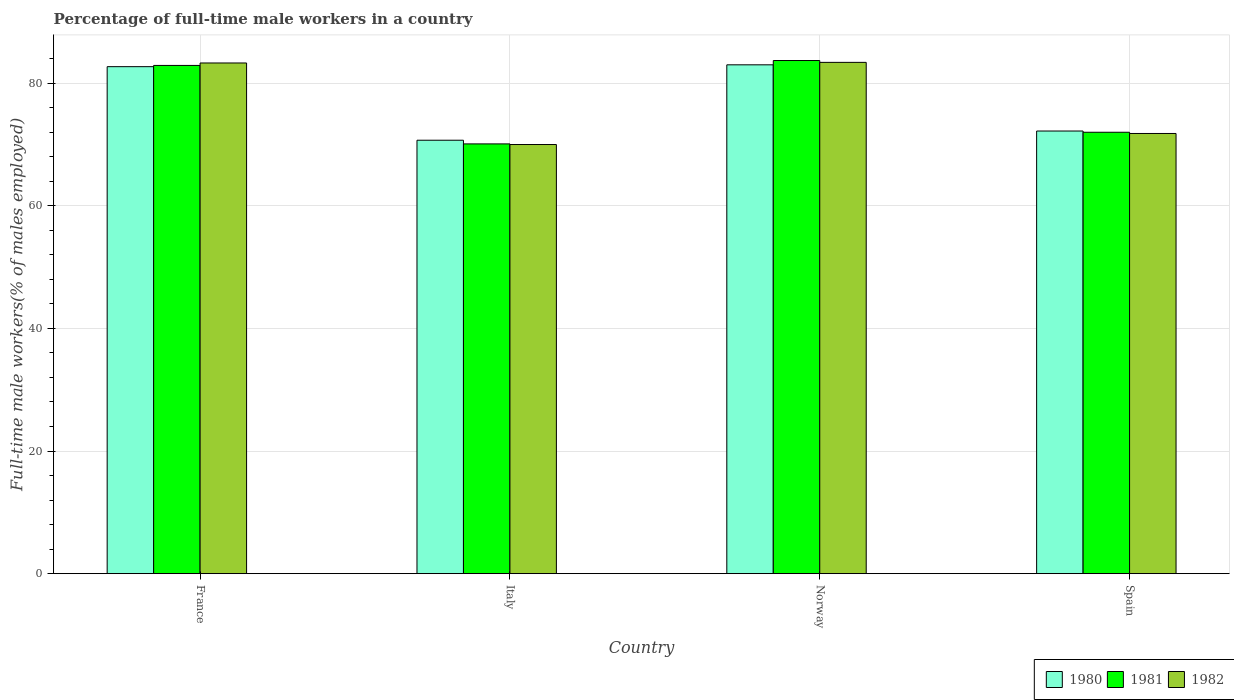Are the number of bars on each tick of the X-axis equal?
Make the answer very short. Yes. How many bars are there on the 4th tick from the left?
Offer a terse response. 3. How many bars are there on the 4th tick from the right?
Provide a short and direct response. 3. What is the label of the 2nd group of bars from the left?
Your answer should be very brief. Italy. In how many cases, is the number of bars for a given country not equal to the number of legend labels?
Offer a very short reply. 0. Across all countries, what is the maximum percentage of full-time male workers in 1982?
Your answer should be compact. 83.4. Across all countries, what is the minimum percentage of full-time male workers in 1980?
Offer a very short reply. 70.7. What is the total percentage of full-time male workers in 1981 in the graph?
Keep it short and to the point. 308.7. What is the difference between the percentage of full-time male workers in 1982 in Spain and the percentage of full-time male workers in 1981 in Norway?
Keep it short and to the point. -11.9. What is the average percentage of full-time male workers in 1981 per country?
Make the answer very short. 77.17. What is the difference between the percentage of full-time male workers of/in 1981 and percentage of full-time male workers of/in 1982 in France?
Offer a terse response. -0.4. In how many countries, is the percentage of full-time male workers in 1981 greater than 24 %?
Your answer should be very brief. 4. What is the ratio of the percentage of full-time male workers in 1982 in Italy to that in Norway?
Provide a short and direct response. 0.84. Is the percentage of full-time male workers in 1981 in Norway less than that in Spain?
Your response must be concise. No. Is the difference between the percentage of full-time male workers in 1981 in France and Italy greater than the difference between the percentage of full-time male workers in 1982 in France and Italy?
Provide a short and direct response. No. What is the difference between the highest and the lowest percentage of full-time male workers in 1982?
Give a very brief answer. 13.4. What does the 3rd bar from the right in Norway represents?
Your answer should be very brief. 1980. Are all the bars in the graph horizontal?
Provide a succinct answer. No. How many countries are there in the graph?
Provide a succinct answer. 4. What is the difference between two consecutive major ticks on the Y-axis?
Make the answer very short. 20. Are the values on the major ticks of Y-axis written in scientific E-notation?
Offer a terse response. No. Does the graph contain any zero values?
Ensure brevity in your answer.  No. How many legend labels are there?
Ensure brevity in your answer.  3. How are the legend labels stacked?
Your response must be concise. Horizontal. What is the title of the graph?
Keep it short and to the point. Percentage of full-time male workers in a country. Does "1982" appear as one of the legend labels in the graph?
Ensure brevity in your answer.  Yes. What is the label or title of the X-axis?
Give a very brief answer. Country. What is the label or title of the Y-axis?
Offer a terse response. Full-time male workers(% of males employed). What is the Full-time male workers(% of males employed) of 1980 in France?
Your response must be concise. 82.7. What is the Full-time male workers(% of males employed) in 1981 in France?
Offer a very short reply. 82.9. What is the Full-time male workers(% of males employed) of 1982 in France?
Your answer should be compact. 83.3. What is the Full-time male workers(% of males employed) in 1980 in Italy?
Make the answer very short. 70.7. What is the Full-time male workers(% of males employed) of 1981 in Italy?
Ensure brevity in your answer.  70.1. What is the Full-time male workers(% of males employed) of 1980 in Norway?
Your answer should be very brief. 83. What is the Full-time male workers(% of males employed) of 1981 in Norway?
Your answer should be compact. 83.7. What is the Full-time male workers(% of males employed) in 1982 in Norway?
Provide a succinct answer. 83.4. What is the Full-time male workers(% of males employed) in 1980 in Spain?
Ensure brevity in your answer.  72.2. What is the Full-time male workers(% of males employed) of 1981 in Spain?
Ensure brevity in your answer.  72. What is the Full-time male workers(% of males employed) in 1982 in Spain?
Offer a terse response. 71.8. Across all countries, what is the maximum Full-time male workers(% of males employed) in 1980?
Make the answer very short. 83. Across all countries, what is the maximum Full-time male workers(% of males employed) of 1981?
Make the answer very short. 83.7. Across all countries, what is the maximum Full-time male workers(% of males employed) in 1982?
Provide a short and direct response. 83.4. Across all countries, what is the minimum Full-time male workers(% of males employed) of 1980?
Ensure brevity in your answer.  70.7. Across all countries, what is the minimum Full-time male workers(% of males employed) in 1981?
Your response must be concise. 70.1. What is the total Full-time male workers(% of males employed) of 1980 in the graph?
Keep it short and to the point. 308.6. What is the total Full-time male workers(% of males employed) in 1981 in the graph?
Your answer should be compact. 308.7. What is the total Full-time male workers(% of males employed) in 1982 in the graph?
Offer a terse response. 308.5. What is the difference between the Full-time male workers(% of males employed) in 1980 in France and that in Italy?
Provide a short and direct response. 12. What is the difference between the Full-time male workers(% of males employed) of 1980 in France and that in Spain?
Your response must be concise. 10.5. What is the difference between the Full-time male workers(% of males employed) of 1982 in France and that in Spain?
Your answer should be very brief. 11.5. What is the difference between the Full-time male workers(% of males employed) in 1980 in Italy and that in Spain?
Your answer should be compact. -1.5. What is the difference between the Full-time male workers(% of males employed) in 1982 in Italy and that in Spain?
Your answer should be very brief. -1.8. What is the difference between the Full-time male workers(% of males employed) in 1981 in Norway and that in Spain?
Your answer should be compact. 11.7. What is the difference between the Full-time male workers(% of males employed) in 1980 in France and the Full-time male workers(% of males employed) in 1982 in Italy?
Your response must be concise. 12.7. What is the difference between the Full-time male workers(% of males employed) in 1980 in France and the Full-time male workers(% of males employed) in 1981 in Norway?
Keep it short and to the point. -1. What is the difference between the Full-time male workers(% of males employed) of 1980 in France and the Full-time male workers(% of males employed) of 1982 in Norway?
Make the answer very short. -0.7. What is the difference between the Full-time male workers(% of males employed) in 1981 in France and the Full-time male workers(% of males employed) in 1982 in Norway?
Ensure brevity in your answer.  -0.5. What is the difference between the Full-time male workers(% of males employed) in 1980 in France and the Full-time male workers(% of males employed) in 1982 in Spain?
Offer a terse response. 10.9. What is the difference between the Full-time male workers(% of males employed) of 1981 in France and the Full-time male workers(% of males employed) of 1982 in Spain?
Give a very brief answer. 11.1. What is the difference between the Full-time male workers(% of males employed) of 1980 in Italy and the Full-time male workers(% of males employed) of 1981 in Norway?
Provide a succinct answer. -13. What is the difference between the Full-time male workers(% of males employed) in 1981 in Italy and the Full-time male workers(% of males employed) in 1982 in Norway?
Your answer should be compact. -13.3. What is the average Full-time male workers(% of males employed) in 1980 per country?
Give a very brief answer. 77.15. What is the average Full-time male workers(% of males employed) of 1981 per country?
Your answer should be compact. 77.17. What is the average Full-time male workers(% of males employed) in 1982 per country?
Your response must be concise. 77.12. What is the difference between the Full-time male workers(% of males employed) of 1981 and Full-time male workers(% of males employed) of 1982 in France?
Your answer should be very brief. -0.4. What is the difference between the Full-time male workers(% of males employed) of 1980 and Full-time male workers(% of males employed) of 1981 in Italy?
Ensure brevity in your answer.  0.6. What is the difference between the Full-time male workers(% of males employed) in 1980 and Full-time male workers(% of males employed) in 1982 in Italy?
Your answer should be compact. 0.7. What is the difference between the Full-time male workers(% of males employed) in 1980 and Full-time male workers(% of males employed) in 1982 in Norway?
Your answer should be very brief. -0.4. What is the difference between the Full-time male workers(% of males employed) in 1981 and Full-time male workers(% of males employed) in 1982 in Norway?
Provide a short and direct response. 0.3. What is the difference between the Full-time male workers(% of males employed) in 1980 and Full-time male workers(% of males employed) in 1981 in Spain?
Your response must be concise. 0.2. What is the difference between the Full-time male workers(% of males employed) in 1980 and Full-time male workers(% of males employed) in 1982 in Spain?
Provide a succinct answer. 0.4. What is the difference between the Full-time male workers(% of males employed) in 1981 and Full-time male workers(% of males employed) in 1982 in Spain?
Offer a terse response. 0.2. What is the ratio of the Full-time male workers(% of males employed) in 1980 in France to that in Italy?
Your response must be concise. 1.17. What is the ratio of the Full-time male workers(% of males employed) in 1981 in France to that in Italy?
Ensure brevity in your answer.  1.18. What is the ratio of the Full-time male workers(% of males employed) in 1982 in France to that in Italy?
Keep it short and to the point. 1.19. What is the ratio of the Full-time male workers(% of males employed) in 1980 in France to that in Spain?
Offer a very short reply. 1.15. What is the ratio of the Full-time male workers(% of males employed) of 1981 in France to that in Spain?
Your answer should be very brief. 1.15. What is the ratio of the Full-time male workers(% of males employed) of 1982 in France to that in Spain?
Keep it short and to the point. 1.16. What is the ratio of the Full-time male workers(% of males employed) in 1980 in Italy to that in Norway?
Give a very brief answer. 0.85. What is the ratio of the Full-time male workers(% of males employed) of 1981 in Italy to that in Norway?
Keep it short and to the point. 0.84. What is the ratio of the Full-time male workers(% of males employed) of 1982 in Italy to that in Norway?
Keep it short and to the point. 0.84. What is the ratio of the Full-time male workers(% of males employed) in 1980 in Italy to that in Spain?
Ensure brevity in your answer.  0.98. What is the ratio of the Full-time male workers(% of males employed) in 1981 in Italy to that in Spain?
Give a very brief answer. 0.97. What is the ratio of the Full-time male workers(% of males employed) of 1982 in Italy to that in Spain?
Provide a succinct answer. 0.97. What is the ratio of the Full-time male workers(% of males employed) of 1980 in Norway to that in Spain?
Offer a terse response. 1.15. What is the ratio of the Full-time male workers(% of males employed) in 1981 in Norway to that in Spain?
Provide a succinct answer. 1.16. What is the ratio of the Full-time male workers(% of males employed) in 1982 in Norway to that in Spain?
Keep it short and to the point. 1.16. What is the difference between the highest and the lowest Full-time male workers(% of males employed) in 1980?
Offer a terse response. 12.3. What is the difference between the highest and the lowest Full-time male workers(% of males employed) of 1981?
Make the answer very short. 13.6. What is the difference between the highest and the lowest Full-time male workers(% of males employed) of 1982?
Make the answer very short. 13.4. 